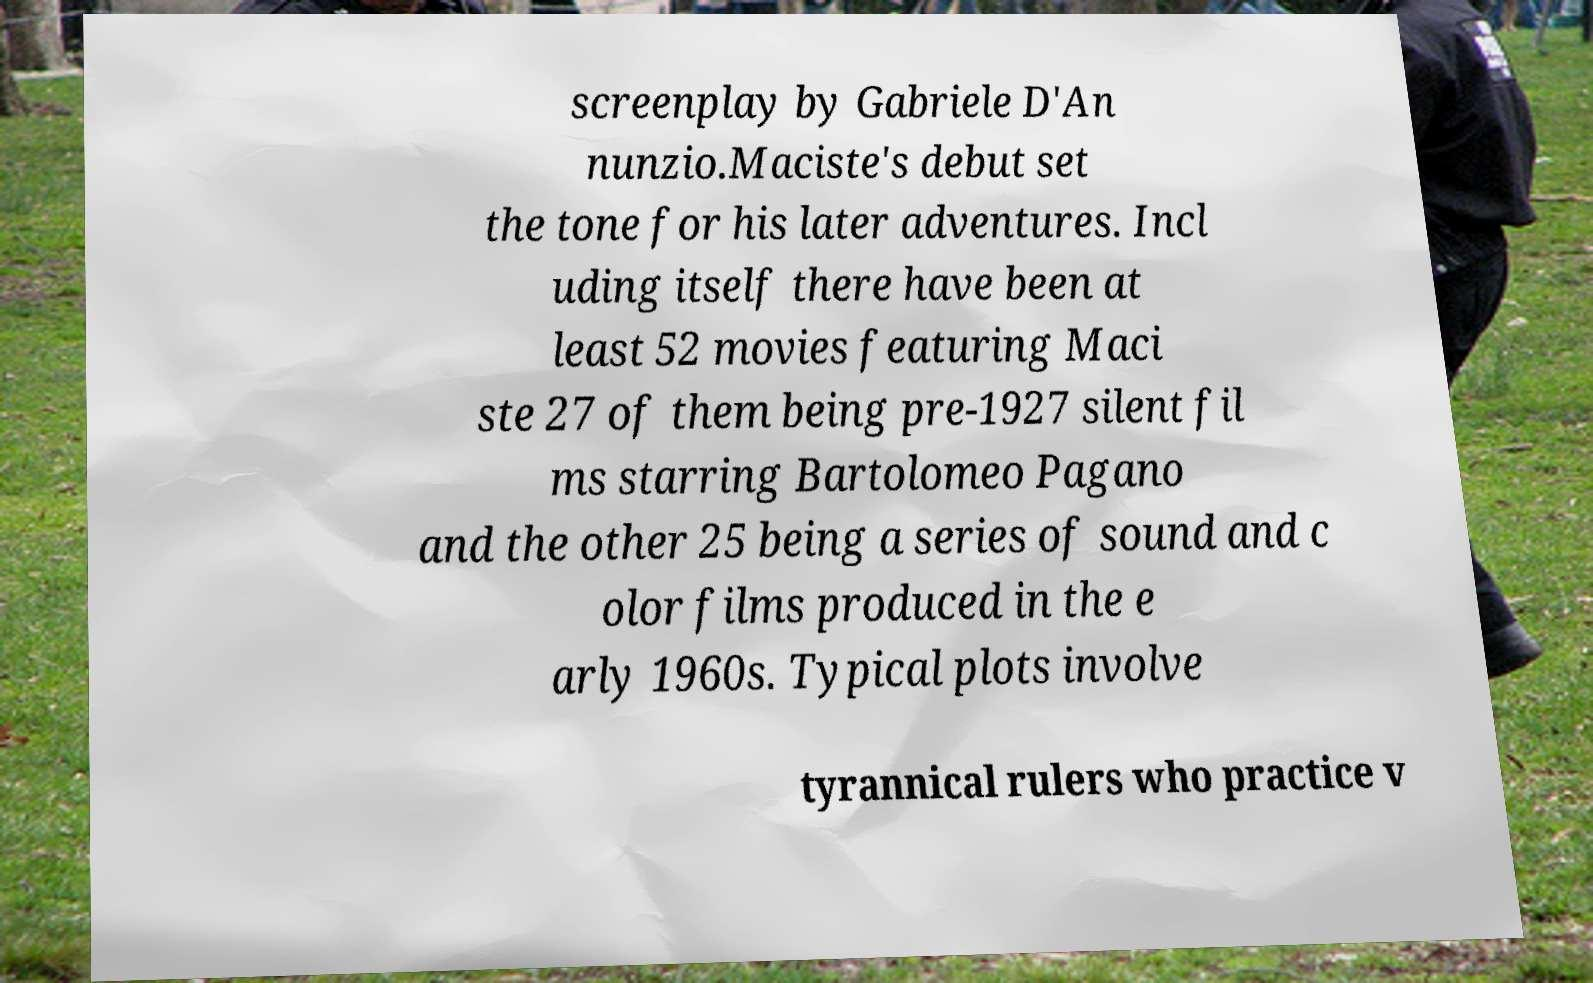Can you read and provide the text displayed in the image?This photo seems to have some interesting text. Can you extract and type it out for me? screenplay by Gabriele D'An nunzio.Maciste's debut set the tone for his later adventures. Incl uding itself there have been at least 52 movies featuring Maci ste 27 of them being pre-1927 silent fil ms starring Bartolomeo Pagano and the other 25 being a series of sound and c olor films produced in the e arly 1960s. Typical plots involve tyrannical rulers who practice v 